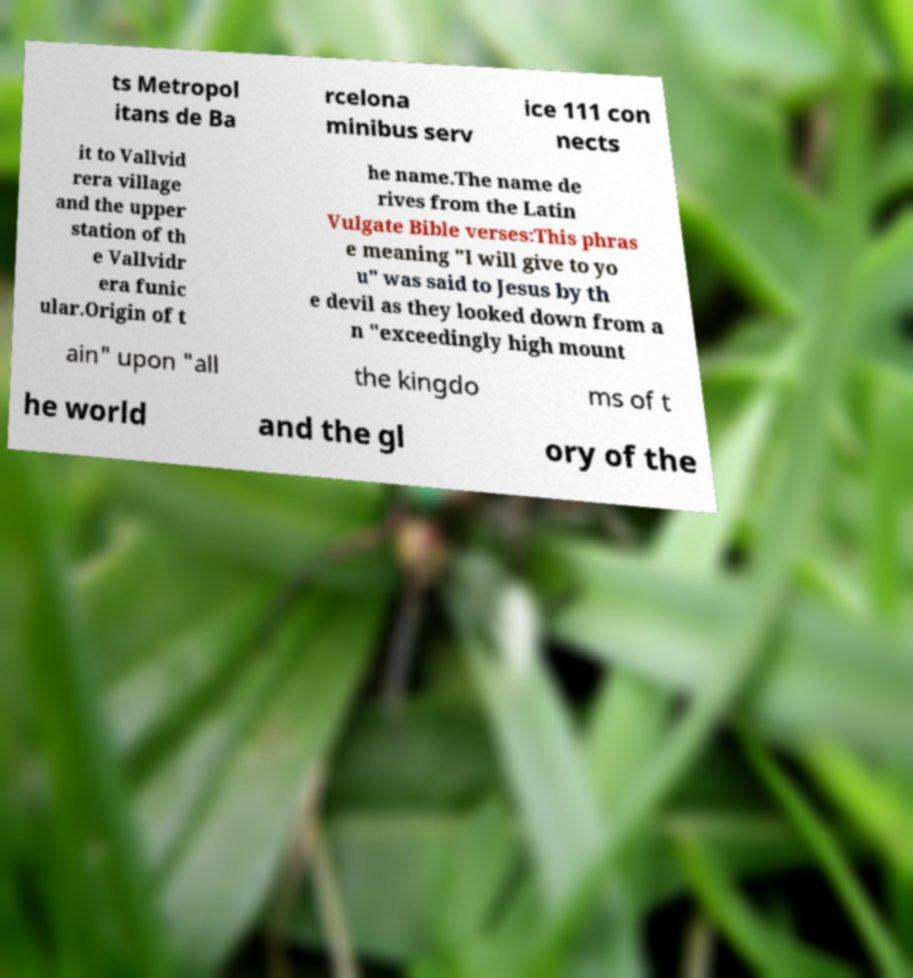What messages or text are displayed in this image? I need them in a readable, typed format. ts Metropol itans de Ba rcelona minibus serv ice 111 con nects it to Vallvid rera village and the upper station of th e Vallvidr era funic ular.Origin of t he name.The name de rives from the Latin Vulgate Bible verses:This phras e meaning "I will give to yo u" was said to Jesus by th e devil as they looked down from a n "exceedingly high mount ain" upon "all the kingdo ms of t he world and the gl ory of the 